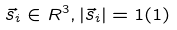Convert formula to latex. <formula><loc_0><loc_0><loc_500><loc_500>\vec { s } _ { i } \in R ^ { 3 } , | \vec { s } _ { i } | = 1 ( 1 )</formula> 